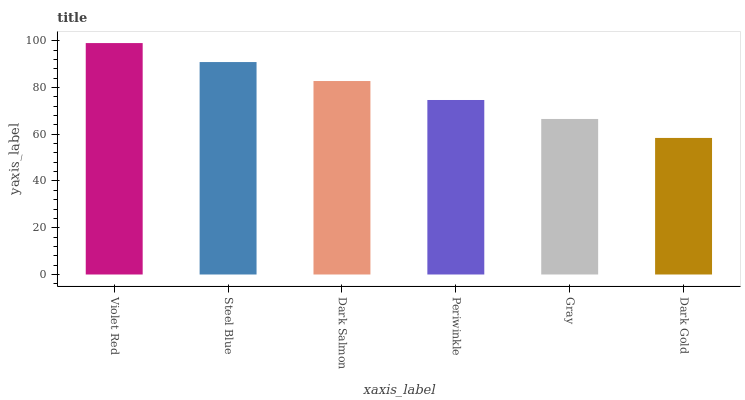Is Dark Gold the minimum?
Answer yes or no. Yes. Is Violet Red the maximum?
Answer yes or no. Yes. Is Steel Blue the minimum?
Answer yes or no. No. Is Steel Blue the maximum?
Answer yes or no. No. Is Violet Red greater than Steel Blue?
Answer yes or no. Yes. Is Steel Blue less than Violet Red?
Answer yes or no. Yes. Is Steel Blue greater than Violet Red?
Answer yes or no. No. Is Violet Red less than Steel Blue?
Answer yes or no. No. Is Dark Salmon the high median?
Answer yes or no. Yes. Is Periwinkle the low median?
Answer yes or no. Yes. Is Dark Gold the high median?
Answer yes or no. No. Is Steel Blue the low median?
Answer yes or no. No. 